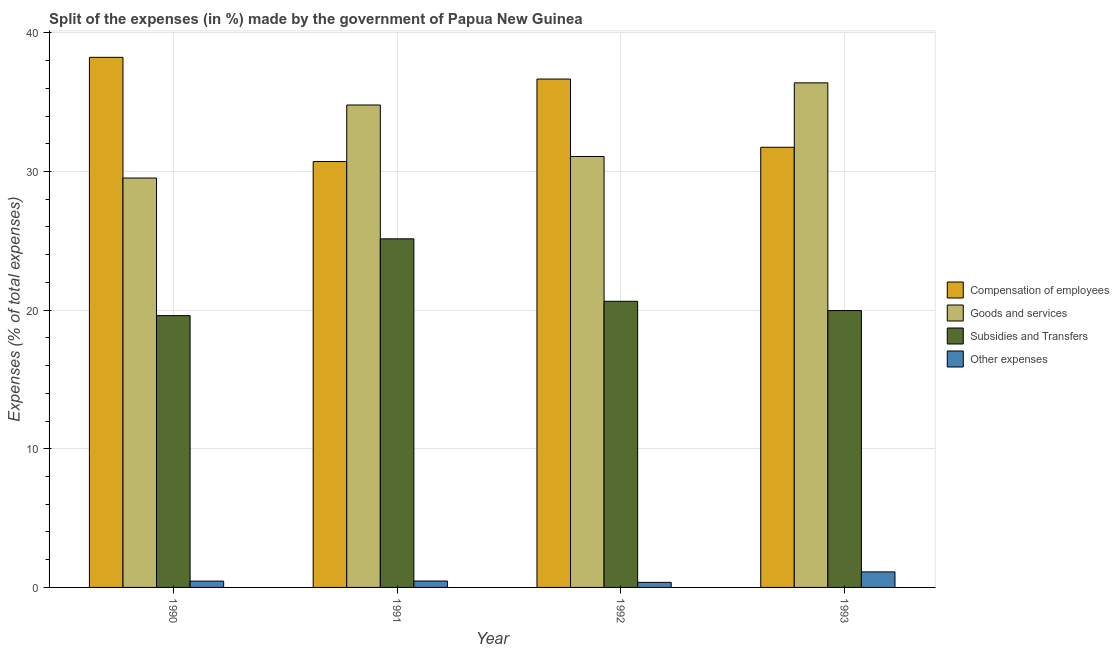How many different coloured bars are there?
Ensure brevity in your answer.  4. How many groups of bars are there?
Offer a very short reply. 4. Are the number of bars per tick equal to the number of legend labels?
Your answer should be compact. Yes. What is the label of the 1st group of bars from the left?
Your response must be concise. 1990. In how many cases, is the number of bars for a given year not equal to the number of legend labels?
Your answer should be compact. 0. What is the percentage of amount spent on other expenses in 1992?
Your response must be concise. 0.37. Across all years, what is the maximum percentage of amount spent on other expenses?
Your answer should be very brief. 1.12. Across all years, what is the minimum percentage of amount spent on compensation of employees?
Your answer should be compact. 30.72. What is the total percentage of amount spent on goods and services in the graph?
Your response must be concise. 131.81. What is the difference between the percentage of amount spent on other expenses in 1991 and that in 1992?
Your answer should be compact. 0.1. What is the difference between the percentage of amount spent on other expenses in 1993 and the percentage of amount spent on compensation of employees in 1991?
Offer a terse response. 0.66. What is the average percentage of amount spent on other expenses per year?
Give a very brief answer. 0.6. In how many years, is the percentage of amount spent on goods and services greater than 12 %?
Give a very brief answer. 4. What is the ratio of the percentage of amount spent on compensation of employees in 1991 to that in 1992?
Provide a short and direct response. 0.84. Is the difference between the percentage of amount spent on subsidies in 1991 and 1993 greater than the difference between the percentage of amount spent on compensation of employees in 1991 and 1993?
Offer a terse response. No. What is the difference between the highest and the second highest percentage of amount spent on other expenses?
Your response must be concise. 0.66. What is the difference between the highest and the lowest percentage of amount spent on other expenses?
Give a very brief answer. 0.76. In how many years, is the percentage of amount spent on compensation of employees greater than the average percentage of amount spent on compensation of employees taken over all years?
Offer a very short reply. 2. Is the sum of the percentage of amount spent on other expenses in 1990 and 1993 greater than the maximum percentage of amount spent on compensation of employees across all years?
Offer a very short reply. Yes. What does the 3rd bar from the left in 1991 represents?
Your answer should be very brief. Subsidies and Transfers. What does the 2nd bar from the right in 1992 represents?
Provide a succinct answer. Subsidies and Transfers. Is it the case that in every year, the sum of the percentage of amount spent on compensation of employees and percentage of amount spent on goods and services is greater than the percentage of amount spent on subsidies?
Keep it short and to the point. Yes. Are all the bars in the graph horizontal?
Make the answer very short. No. How many years are there in the graph?
Make the answer very short. 4. Does the graph contain any zero values?
Your answer should be very brief. No. Where does the legend appear in the graph?
Offer a terse response. Center right. What is the title of the graph?
Keep it short and to the point. Split of the expenses (in %) made by the government of Papua New Guinea. What is the label or title of the X-axis?
Give a very brief answer. Year. What is the label or title of the Y-axis?
Make the answer very short. Expenses (% of total expenses). What is the Expenses (% of total expenses) of Compensation of employees in 1990?
Give a very brief answer. 38.24. What is the Expenses (% of total expenses) of Goods and services in 1990?
Offer a very short reply. 29.53. What is the Expenses (% of total expenses) of Subsidies and Transfers in 1990?
Your answer should be very brief. 19.61. What is the Expenses (% of total expenses) of Other expenses in 1990?
Your answer should be compact. 0.46. What is the Expenses (% of total expenses) in Compensation of employees in 1991?
Keep it short and to the point. 30.72. What is the Expenses (% of total expenses) of Goods and services in 1991?
Keep it short and to the point. 34.8. What is the Expenses (% of total expenses) in Subsidies and Transfers in 1991?
Your response must be concise. 25.15. What is the Expenses (% of total expenses) in Other expenses in 1991?
Keep it short and to the point. 0.46. What is the Expenses (% of total expenses) in Compensation of employees in 1992?
Ensure brevity in your answer.  36.67. What is the Expenses (% of total expenses) in Goods and services in 1992?
Provide a succinct answer. 31.08. What is the Expenses (% of total expenses) in Subsidies and Transfers in 1992?
Your answer should be very brief. 20.64. What is the Expenses (% of total expenses) in Other expenses in 1992?
Your answer should be compact. 0.37. What is the Expenses (% of total expenses) in Compensation of employees in 1993?
Keep it short and to the point. 31.75. What is the Expenses (% of total expenses) of Goods and services in 1993?
Your answer should be very brief. 36.4. What is the Expenses (% of total expenses) of Subsidies and Transfers in 1993?
Keep it short and to the point. 19.97. What is the Expenses (% of total expenses) of Other expenses in 1993?
Ensure brevity in your answer.  1.12. Across all years, what is the maximum Expenses (% of total expenses) in Compensation of employees?
Your response must be concise. 38.24. Across all years, what is the maximum Expenses (% of total expenses) of Goods and services?
Your response must be concise. 36.4. Across all years, what is the maximum Expenses (% of total expenses) of Subsidies and Transfers?
Give a very brief answer. 25.15. Across all years, what is the maximum Expenses (% of total expenses) of Other expenses?
Your answer should be very brief. 1.12. Across all years, what is the minimum Expenses (% of total expenses) in Compensation of employees?
Your response must be concise. 30.72. Across all years, what is the minimum Expenses (% of total expenses) in Goods and services?
Make the answer very short. 29.53. Across all years, what is the minimum Expenses (% of total expenses) of Subsidies and Transfers?
Keep it short and to the point. 19.61. Across all years, what is the minimum Expenses (% of total expenses) of Other expenses?
Your answer should be very brief. 0.37. What is the total Expenses (% of total expenses) of Compensation of employees in the graph?
Provide a short and direct response. 137.38. What is the total Expenses (% of total expenses) in Goods and services in the graph?
Your answer should be compact. 131.81. What is the total Expenses (% of total expenses) of Subsidies and Transfers in the graph?
Your answer should be very brief. 85.36. What is the total Expenses (% of total expenses) of Other expenses in the graph?
Provide a short and direct response. 2.41. What is the difference between the Expenses (% of total expenses) in Compensation of employees in 1990 and that in 1991?
Your answer should be compact. 7.52. What is the difference between the Expenses (% of total expenses) of Goods and services in 1990 and that in 1991?
Keep it short and to the point. -5.27. What is the difference between the Expenses (% of total expenses) in Subsidies and Transfers in 1990 and that in 1991?
Your response must be concise. -5.54. What is the difference between the Expenses (% of total expenses) in Other expenses in 1990 and that in 1991?
Make the answer very short. -0.01. What is the difference between the Expenses (% of total expenses) of Compensation of employees in 1990 and that in 1992?
Provide a succinct answer. 1.57. What is the difference between the Expenses (% of total expenses) of Goods and services in 1990 and that in 1992?
Give a very brief answer. -1.55. What is the difference between the Expenses (% of total expenses) of Subsidies and Transfers in 1990 and that in 1992?
Give a very brief answer. -1.03. What is the difference between the Expenses (% of total expenses) in Other expenses in 1990 and that in 1992?
Give a very brief answer. 0.09. What is the difference between the Expenses (% of total expenses) in Compensation of employees in 1990 and that in 1993?
Provide a succinct answer. 6.49. What is the difference between the Expenses (% of total expenses) in Goods and services in 1990 and that in 1993?
Offer a very short reply. -6.87. What is the difference between the Expenses (% of total expenses) of Subsidies and Transfers in 1990 and that in 1993?
Your response must be concise. -0.37. What is the difference between the Expenses (% of total expenses) of Other expenses in 1990 and that in 1993?
Give a very brief answer. -0.67. What is the difference between the Expenses (% of total expenses) in Compensation of employees in 1991 and that in 1992?
Offer a very short reply. -5.95. What is the difference between the Expenses (% of total expenses) of Goods and services in 1991 and that in 1992?
Keep it short and to the point. 3.71. What is the difference between the Expenses (% of total expenses) in Subsidies and Transfers in 1991 and that in 1992?
Provide a short and direct response. 4.51. What is the difference between the Expenses (% of total expenses) in Other expenses in 1991 and that in 1992?
Provide a short and direct response. 0.1. What is the difference between the Expenses (% of total expenses) of Compensation of employees in 1991 and that in 1993?
Provide a short and direct response. -1.03. What is the difference between the Expenses (% of total expenses) of Goods and services in 1991 and that in 1993?
Offer a terse response. -1.6. What is the difference between the Expenses (% of total expenses) in Subsidies and Transfers in 1991 and that in 1993?
Make the answer very short. 5.17. What is the difference between the Expenses (% of total expenses) of Other expenses in 1991 and that in 1993?
Your response must be concise. -0.66. What is the difference between the Expenses (% of total expenses) in Compensation of employees in 1992 and that in 1993?
Your answer should be compact. 4.92. What is the difference between the Expenses (% of total expenses) in Goods and services in 1992 and that in 1993?
Keep it short and to the point. -5.31. What is the difference between the Expenses (% of total expenses) of Subsidies and Transfers in 1992 and that in 1993?
Your answer should be very brief. 0.67. What is the difference between the Expenses (% of total expenses) in Other expenses in 1992 and that in 1993?
Your answer should be compact. -0.76. What is the difference between the Expenses (% of total expenses) of Compensation of employees in 1990 and the Expenses (% of total expenses) of Goods and services in 1991?
Ensure brevity in your answer.  3.44. What is the difference between the Expenses (% of total expenses) in Compensation of employees in 1990 and the Expenses (% of total expenses) in Subsidies and Transfers in 1991?
Ensure brevity in your answer.  13.09. What is the difference between the Expenses (% of total expenses) in Compensation of employees in 1990 and the Expenses (% of total expenses) in Other expenses in 1991?
Your response must be concise. 37.77. What is the difference between the Expenses (% of total expenses) of Goods and services in 1990 and the Expenses (% of total expenses) of Subsidies and Transfers in 1991?
Offer a very short reply. 4.39. What is the difference between the Expenses (% of total expenses) in Goods and services in 1990 and the Expenses (% of total expenses) in Other expenses in 1991?
Keep it short and to the point. 29.07. What is the difference between the Expenses (% of total expenses) of Subsidies and Transfers in 1990 and the Expenses (% of total expenses) of Other expenses in 1991?
Your answer should be compact. 19.14. What is the difference between the Expenses (% of total expenses) of Compensation of employees in 1990 and the Expenses (% of total expenses) of Goods and services in 1992?
Offer a terse response. 7.15. What is the difference between the Expenses (% of total expenses) in Compensation of employees in 1990 and the Expenses (% of total expenses) in Subsidies and Transfers in 1992?
Offer a terse response. 17.6. What is the difference between the Expenses (% of total expenses) in Compensation of employees in 1990 and the Expenses (% of total expenses) in Other expenses in 1992?
Your response must be concise. 37.87. What is the difference between the Expenses (% of total expenses) of Goods and services in 1990 and the Expenses (% of total expenses) of Subsidies and Transfers in 1992?
Ensure brevity in your answer.  8.89. What is the difference between the Expenses (% of total expenses) of Goods and services in 1990 and the Expenses (% of total expenses) of Other expenses in 1992?
Provide a succinct answer. 29.17. What is the difference between the Expenses (% of total expenses) of Subsidies and Transfers in 1990 and the Expenses (% of total expenses) of Other expenses in 1992?
Ensure brevity in your answer.  19.24. What is the difference between the Expenses (% of total expenses) of Compensation of employees in 1990 and the Expenses (% of total expenses) of Goods and services in 1993?
Your answer should be very brief. 1.84. What is the difference between the Expenses (% of total expenses) of Compensation of employees in 1990 and the Expenses (% of total expenses) of Subsidies and Transfers in 1993?
Provide a succinct answer. 18.27. What is the difference between the Expenses (% of total expenses) of Compensation of employees in 1990 and the Expenses (% of total expenses) of Other expenses in 1993?
Offer a terse response. 37.12. What is the difference between the Expenses (% of total expenses) in Goods and services in 1990 and the Expenses (% of total expenses) in Subsidies and Transfers in 1993?
Give a very brief answer. 9.56. What is the difference between the Expenses (% of total expenses) in Goods and services in 1990 and the Expenses (% of total expenses) in Other expenses in 1993?
Offer a very short reply. 28.41. What is the difference between the Expenses (% of total expenses) of Subsidies and Transfers in 1990 and the Expenses (% of total expenses) of Other expenses in 1993?
Make the answer very short. 18.48. What is the difference between the Expenses (% of total expenses) of Compensation of employees in 1991 and the Expenses (% of total expenses) of Goods and services in 1992?
Make the answer very short. -0.36. What is the difference between the Expenses (% of total expenses) in Compensation of employees in 1991 and the Expenses (% of total expenses) in Subsidies and Transfers in 1992?
Provide a succinct answer. 10.08. What is the difference between the Expenses (% of total expenses) in Compensation of employees in 1991 and the Expenses (% of total expenses) in Other expenses in 1992?
Your answer should be compact. 30.36. What is the difference between the Expenses (% of total expenses) of Goods and services in 1991 and the Expenses (% of total expenses) of Subsidies and Transfers in 1992?
Provide a short and direct response. 14.16. What is the difference between the Expenses (% of total expenses) in Goods and services in 1991 and the Expenses (% of total expenses) in Other expenses in 1992?
Your answer should be compact. 34.43. What is the difference between the Expenses (% of total expenses) in Subsidies and Transfers in 1991 and the Expenses (% of total expenses) in Other expenses in 1992?
Provide a short and direct response. 24.78. What is the difference between the Expenses (% of total expenses) of Compensation of employees in 1991 and the Expenses (% of total expenses) of Goods and services in 1993?
Your response must be concise. -5.68. What is the difference between the Expenses (% of total expenses) in Compensation of employees in 1991 and the Expenses (% of total expenses) in Subsidies and Transfers in 1993?
Your answer should be compact. 10.75. What is the difference between the Expenses (% of total expenses) of Compensation of employees in 1991 and the Expenses (% of total expenses) of Other expenses in 1993?
Offer a terse response. 29.6. What is the difference between the Expenses (% of total expenses) in Goods and services in 1991 and the Expenses (% of total expenses) in Subsidies and Transfers in 1993?
Offer a terse response. 14.83. What is the difference between the Expenses (% of total expenses) in Goods and services in 1991 and the Expenses (% of total expenses) in Other expenses in 1993?
Give a very brief answer. 33.68. What is the difference between the Expenses (% of total expenses) in Subsidies and Transfers in 1991 and the Expenses (% of total expenses) in Other expenses in 1993?
Your answer should be very brief. 24.02. What is the difference between the Expenses (% of total expenses) of Compensation of employees in 1992 and the Expenses (% of total expenses) of Goods and services in 1993?
Provide a short and direct response. 0.27. What is the difference between the Expenses (% of total expenses) in Compensation of employees in 1992 and the Expenses (% of total expenses) in Subsidies and Transfers in 1993?
Offer a very short reply. 16.7. What is the difference between the Expenses (% of total expenses) of Compensation of employees in 1992 and the Expenses (% of total expenses) of Other expenses in 1993?
Make the answer very short. 35.55. What is the difference between the Expenses (% of total expenses) in Goods and services in 1992 and the Expenses (% of total expenses) in Subsidies and Transfers in 1993?
Offer a terse response. 11.11. What is the difference between the Expenses (% of total expenses) of Goods and services in 1992 and the Expenses (% of total expenses) of Other expenses in 1993?
Offer a terse response. 29.96. What is the difference between the Expenses (% of total expenses) in Subsidies and Transfers in 1992 and the Expenses (% of total expenses) in Other expenses in 1993?
Ensure brevity in your answer.  19.52. What is the average Expenses (% of total expenses) of Compensation of employees per year?
Keep it short and to the point. 34.34. What is the average Expenses (% of total expenses) of Goods and services per year?
Offer a very short reply. 32.95. What is the average Expenses (% of total expenses) of Subsidies and Transfers per year?
Your answer should be compact. 21.34. What is the average Expenses (% of total expenses) of Other expenses per year?
Provide a succinct answer. 0.6. In the year 1990, what is the difference between the Expenses (% of total expenses) of Compensation of employees and Expenses (% of total expenses) of Goods and services?
Keep it short and to the point. 8.71. In the year 1990, what is the difference between the Expenses (% of total expenses) in Compensation of employees and Expenses (% of total expenses) in Subsidies and Transfers?
Your answer should be very brief. 18.63. In the year 1990, what is the difference between the Expenses (% of total expenses) of Compensation of employees and Expenses (% of total expenses) of Other expenses?
Give a very brief answer. 37.78. In the year 1990, what is the difference between the Expenses (% of total expenses) in Goods and services and Expenses (% of total expenses) in Subsidies and Transfers?
Ensure brevity in your answer.  9.93. In the year 1990, what is the difference between the Expenses (% of total expenses) of Goods and services and Expenses (% of total expenses) of Other expenses?
Keep it short and to the point. 29.08. In the year 1990, what is the difference between the Expenses (% of total expenses) of Subsidies and Transfers and Expenses (% of total expenses) of Other expenses?
Your answer should be compact. 19.15. In the year 1991, what is the difference between the Expenses (% of total expenses) of Compensation of employees and Expenses (% of total expenses) of Goods and services?
Your answer should be compact. -4.08. In the year 1991, what is the difference between the Expenses (% of total expenses) in Compensation of employees and Expenses (% of total expenses) in Subsidies and Transfers?
Keep it short and to the point. 5.58. In the year 1991, what is the difference between the Expenses (% of total expenses) in Compensation of employees and Expenses (% of total expenses) in Other expenses?
Make the answer very short. 30.26. In the year 1991, what is the difference between the Expenses (% of total expenses) of Goods and services and Expenses (% of total expenses) of Subsidies and Transfers?
Keep it short and to the point. 9.65. In the year 1991, what is the difference between the Expenses (% of total expenses) of Goods and services and Expenses (% of total expenses) of Other expenses?
Provide a short and direct response. 34.34. In the year 1991, what is the difference between the Expenses (% of total expenses) in Subsidies and Transfers and Expenses (% of total expenses) in Other expenses?
Your answer should be compact. 24.68. In the year 1992, what is the difference between the Expenses (% of total expenses) in Compensation of employees and Expenses (% of total expenses) in Goods and services?
Ensure brevity in your answer.  5.59. In the year 1992, what is the difference between the Expenses (% of total expenses) in Compensation of employees and Expenses (% of total expenses) in Subsidies and Transfers?
Offer a terse response. 16.03. In the year 1992, what is the difference between the Expenses (% of total expenses) in Compensation of employees and Expenses (% of total expenses) in Other expenses?
Your response must be concise. 36.31. In the year 1992, what is the difference between the Expenses (% of total expenses) in Goods and services and Expenses (% of total expenses) in Subsidies and Transfers?
Ensure brevity in your answer.  10.44. In the year 1992, what is the difference between the Expenses (% of total expenses) of Goods and services and Expenses (% of total expenses) of Other expenses?
Your response must be concise. 30.72. In the year 1992, what is the difference between the Expenses (% of total expenses) in Subsidies and Transfers and Expenses (% of total expenses) in Other expenses?
Give a very brief answer. 20.28. In the year 1993, what is the difference between the Expenses (% of total expenses) in Compensation of employees and Expenses (% of total expenses) in Goods and services?
Give a very brief answer. -4.65. In the year 1993, what is the difference between the Expenses (% of total expenses) in Compensation of employees and Expenses (% of total expenses) in Subsidies and Transfers?
Make the answer very short. 11.78. In the year 1993, what is the difference between the Expenses (% of total expenses) in Compensation of employees and Expenses (% of total expenses) in Other expenses?
Your response must be concise. 30.63. In the year 1993, what is the difference between the Expenses (% of total expenses) of Goods and services and Expenses (% of total expenses) of Subsidies and Transfers?
Give a very brief answer. 16.43. In the year 1993, what is the difference between the Expenses (% of total expenses) in Goods and services and Expenses (% of total expenses) in Other expenses?
Your answer should be very brief. 35.28. In the year 1993, what is the difference between the Expenses (% of total expenses) in Subsidies and Transfers and Expenses (% of total expenses) in Other expenses?
Provide a succinct answer. 18.85. What is the ratio of the Expenses (% of total expenses) in Compensation of employees in 1990 to that in 1991?
Provide a succinct answer. 1.24. What is the ratio of the Expenses (% of total expenses) in Goods and services in 1990 to that in 1991?
Provide a short and direct response. 0.85. What is the ratio of the Expenses (% of total expenses) in Subsidies and Transfers in 1990 to that in 1991?
Your response must be concise. 0.78. What is the ratio of the Expenses (% of total expenses) in Other expenses in 1990 to that in 1991?
Your answer should be very brief. 0.98. What is the ratio of the Expenses (% of total expenses) in Compensation of employees in 1990 to that in 1992?
Offer a terse response. 1.04. What is the ratio of the Expenses (% of total expenses) in Goods and services in 1990 to that in 1992?
Your answer should be very brief. 0.95. What is the ratio of the Expenses (% of total expenses) in Subsidies and Transfers in 1990 to that in 1992?
Offer a terse response. 0.95. What is the ratio of the Expenses (% of total expenses) in Other expenses in 1990 to that in 1992?
Keep it short and to the point. 1.25. What is the ratio of the Expenses (% of total expenses) in Compensation of employees in 1990 to that in 1993?
Your answer should be compact. 1.2. What is the ratio of the Expenses (% of total expenses) of Goods and services in 1990 to that in 1993?
Offer a very short reply. 0.81. What is the ratio of the Expenses (% of total expenses) in Subsidies and Transfers in 1990 to that in 1993?
Your response must be concise. 0.98. What is the ratio of the Expenses (% of total expenses) of Other expenses in 1990 to that in 1993?
Keep it short and to the point. 0.41. What is the ratio of the Expenses (% of total expenses) in Compensation of employees in 1991 to that in 1992?
Provide a succinct answer. 0.84. What is the ratio of the Expenses (% of total expenses) in Goods and services in 1991 to that in 1992?
Provide a succinct answer. 1.12. What is the ratio of the Expenses (% of total expenses) in Subsidies and Transfers in 1991 to that in 1992?
Provide a short and direct response. 1.22. What is the ratio of the Expenses (% of total expenses) in Other expenses in 1991 to that in 1992?
Make the answer very short. 1.27. What is the ratio of the Expenses (% of total expenses) in Compensation of employees in 1991 to that in 1993?
Keep it short and to the point. 0.97. What is the ratio of the Expenses (% of total expenses) in Goods and services in 1991 to that in 1993?
Ensure brevity in your answer.  0.96. What is the ratio of the Expenses (% of total expenses) of Subsidies and Transfers in 1991 to that in 1993?
Your response must be concise. 1.26. What is the ratio of the Expenses (% of total expenses) in Other expenses in 1991 to that in 1993?
Your answer should be compact. 0.41. What is the ratio of the Expenses (% of total expenses) in Compensation of employees in 1992 to that in 1993?
Offer a terse response. 1.16. What is the ratio of the Expenses (% of total expenses) in Goods and services in 1992 to that in 1993?
Ensure brevity in your answer.  0.85. What is the ratio of the Expenses (% of total expenses) in Subsidies and Transfers in 1992 to that in 1993?
Offer a terse response. 1.03. What is the ratio of the Expenses (% of total expenses) in Other expenses in 1992 to that in 1993?
Your answer should be compact. 0.33. What is the difference between the highest and the second highest Expenses (% of total expenses) of Compensation of employees?
Your answer should be very brief. 1.57. What is the difference between the highest and the second highest Expenses (% of total expenses) of Goods and services?
Your response must be concise. 1.6. What is the difference between the highest and the second highest Expenses (% of total expenses) in Subsidies and Transfers?
Your response must be concise. 4.51. What is the difference between the highest and the second highest Expenses (% of total expenses) in Other expenses?
Make the answer very short. 0.66. What is the difference between the highest and the lowest Expenses (% of total expenses) in Compensation of employees?
Provide a succinct answer. 7.52. What is the difference between the highest and the lowest Expenses (% of total expenses) in Goods and services?
Make the answer very short. 6.87. What is the difference between the highest and the lowest Expenses (% of total expenses) in Subsidies and Transfers?
Your answer should be very brief. 5.54. What is the difference between the highest and the lowest Expenses (% of total expenses) of Other expenses?
Provide a short and direct response. 0.76. 